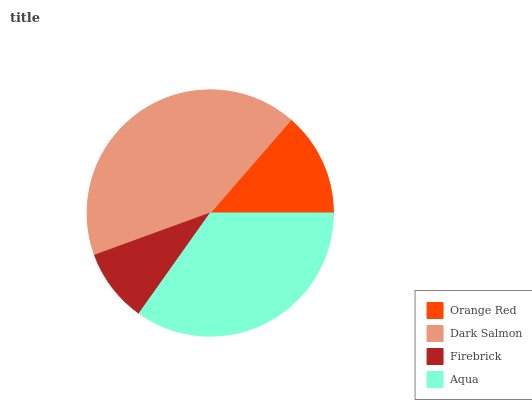Is Firebrick the minimum?
Answer yes or no. Yes. Is Dark Salmon the maximum?
Answer yes or no. Yes. Is Dark Salmon the minimum?
Answer yes or no. No. Is Firebrick the maximum?
Answer yes or no. No. Is Dark Salmon greater than Firebrick?
Answer yes or no. Yes. Is Firebrick less than Dark Salmon?
Answer yes or no. Yes. Is Firebrick greater than Dark Salmon?
Answer yes or no. No. Is Dark Salmon less than Firebrick?
Answer yes or no. No. Is Aqua the high median?
Answer yes or no. Yes. Is Orange Red the low median?
Answer yes or no. Yes. Is Firebrick the high median?
Answer yes or no. No. Is Dark Salmon the low median?
Answer yes or no. No. 